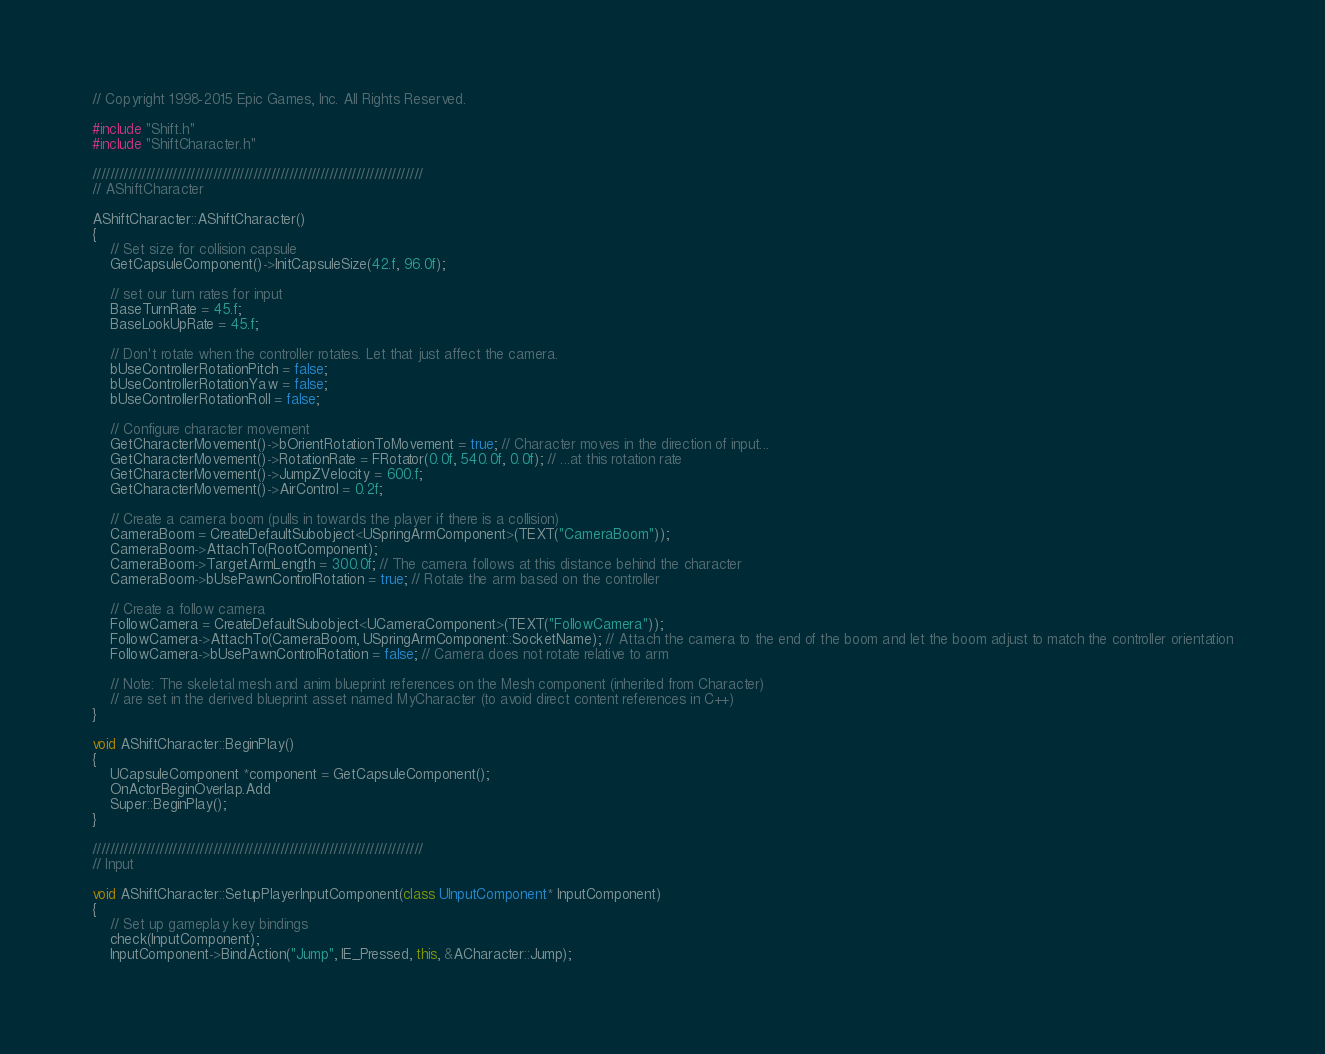<code> <loc_0><loc_0><loc_500><loc_500><_C++_>// Copyright 1998-2015 Epic Games, Inc. All Rights Reserved.

#include "Shift.h"
#include "ShiftCharacter.h"

//////////////////////////////////////////////////////////////////////////
// AShiftCharacter

AShiftCharacter::AShiftCharacter()
{
	// Set size for collision capsule
	GetCapsuleComponent()->InitCapsuleSize(42.f, 96.0f);

	// set our turn rates for input
	BaseTurnRate = 45.f;
	BaseLookUpRate = 45.f;

	// Don't rotate when the controller rotates. Let that just affect the camera.
	bUseControllerRotationPitch = false;
	bUseControllerRotationYaw = false;
	bUseControllerRotationRoll = false;

	// Configure character movement
	GetCharacterMovement()->bOrientRotationToMovement = true; // Character moves in the direction of input...	
	GetCharacterMovement()->RotationRate = FRotator(0.0f, 540.0f, 0.0f); // ...at this rotation rate
	GetCharacterMovement()->JumpZVelocity = 600.f;
	GetCharacterMovement()->AirControl = 0.2f;

	// Create a camera boom (pulls in towards the player if there is a collision)
	CameraBoom = CreateDefaultSubobject<USpringArmComponent>(TEXT("CameraBoom"));
	CameraBoom->AttachTo(RootComponent);
	CameraBoom->TargetArmLength = 300.0f; // The camera follows at this distance behind the character	
	CameraBoom->bUsePawnControlRotation = true; // Rotate the arm based on the controller

	// Create a follow camera
	FollowCamera = CreateDefaultSubobject<UCameraComponent>(TEXT("FollowCamera"));
	FollowCamera->AttachTo(CameraBoom, USpringArmComponent::SocketName); // Attach the camera to the end of the boom and let the boom adjust to match the controller orientation
	FollowCamera->bUsePawnControlRotation = false; // Camera does not rotate relative to arm

	// Note: The skeletal mesh and anim blueprint references on the Mesh component (inherited from Character) 
	// are set in the derived blueprint asset named MyCharacter (to avoid direct content references in C++)
}

void AShiftCharacter::BeginPlay()
{
	UCapsuleComponent *component = GetCapsuleComponent();
	OnActorBeginOverlap.Add
	Super::BeginPlay();
}

//////////////////////////////////////////////////////////////////////////
// Input

void AShiftCharacter::SetupPlayerInputComponent(class UInputComponent* InputComponent)
{
	// Set up gameplay key bindings
	check(InputComponent);
	InputComponent->BindAction("Jump", IE_Pressed, this, &ACharacter::Jump);</code> 